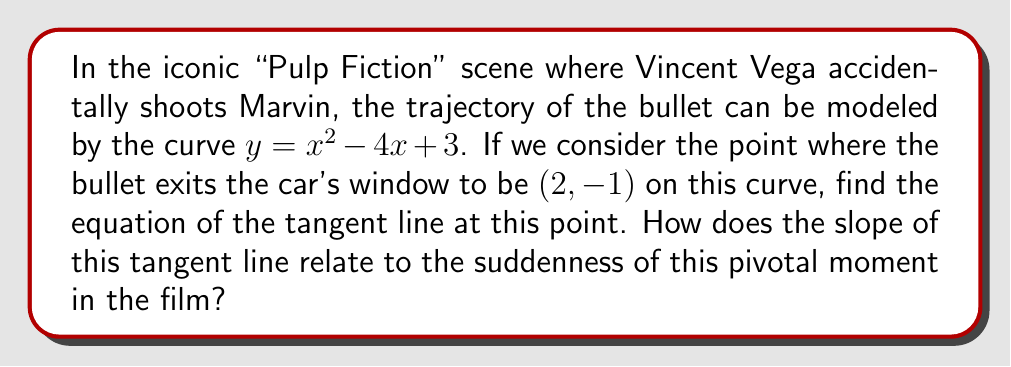Can you answer this question? To find the equation of the tangent line, we need to follow these steps:

1) First, we need to find the derivative of the given function:
   $f(x) = x^2 - 4x + 3$
   $f'(x) = 2x - 4$

2) Now, we evaluate the derivative at the given point $(2, -1)$:
   $f'(2) = 2(2) - 4 = 0$

3) The slope of the tangent line is the value of the derivative at the point. So, the slope is 0.

4) We can now use the point-slope form of a line to write the equation of the tangent line:
   $y - y_1 = m(x - x_1)$
   Where $(x_1, y_1)$ is the point $(2, -1)$ and $m$ is the slope we just calculated (0).

5) Substituting these values:
   $y - (-1) = 0(x - 2)$

6) Simplifying:
   $y + 1 = 0$
   $y = -1$

The slope of 0 relates to the suddenness of the moment in the film. Just as the horizontal tangent line represents a momentary pause in the curve's ascent or descent, the accidental shooting creates a sudden, shocking pause in the film's narrative flow.
Answer: $y = -1$ 